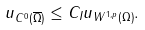<formula> <loc_0><loc_0><loc_500><loc_500>\| u \| _ { C ^ { 0 } ( \overline { \Omega } ) } \leq C _ { I } \| u \| _ { W ^ { 1 , p } ( \Omega ) } .</formula> 